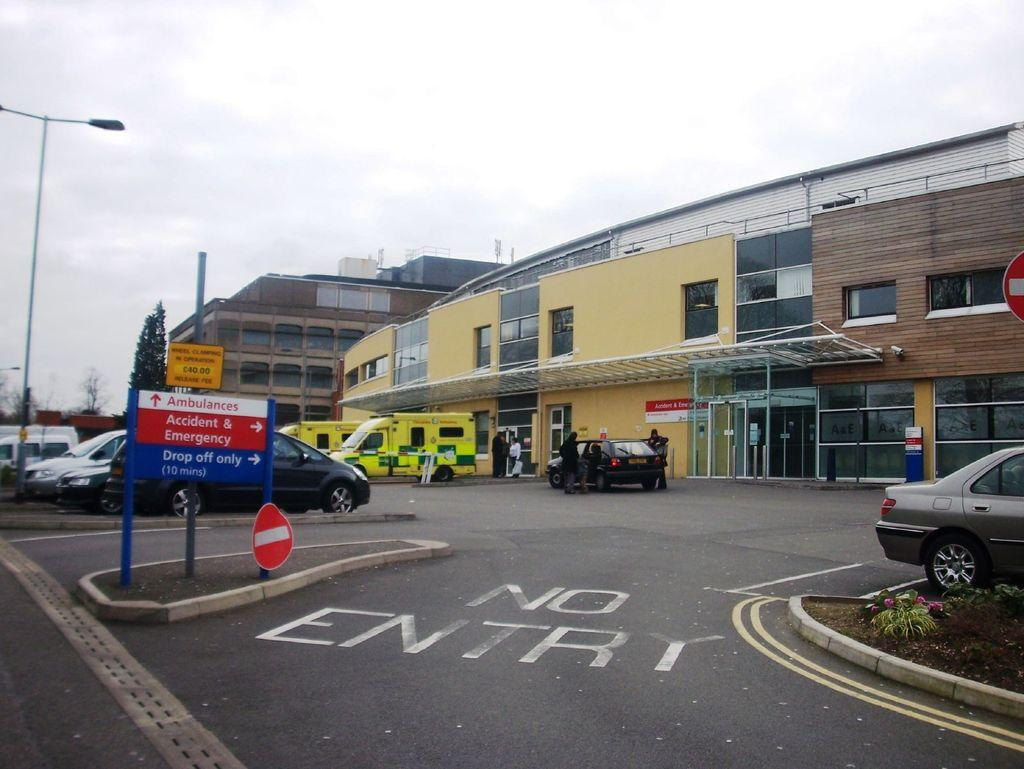What type of structures can be seen in the image? There are buildings in the image. What mode of transportation is present in the image? There are vehicles and cars in the image. Are there any people visible in the image? Yes, there are persons in the image. What architectural feature can be seen on the buildings? There is a door and windows in the image. What type of lighting is present in the image? There is a street light in the image. What type of signage is present in the image? There are sign boards in the image. What type of natural elements can be seen in the image? There are flowers, plants, and trees in the image. What part of the natural environment is visible in the image? The sky is visible in the image, with clouds present. What type of lead can be seen being used by the person in the image? There is no lead visible in the image, and no person is shown using any lead. What type of mitten is being worn by the person in the image? There is no person wearing a mitten in the image. 